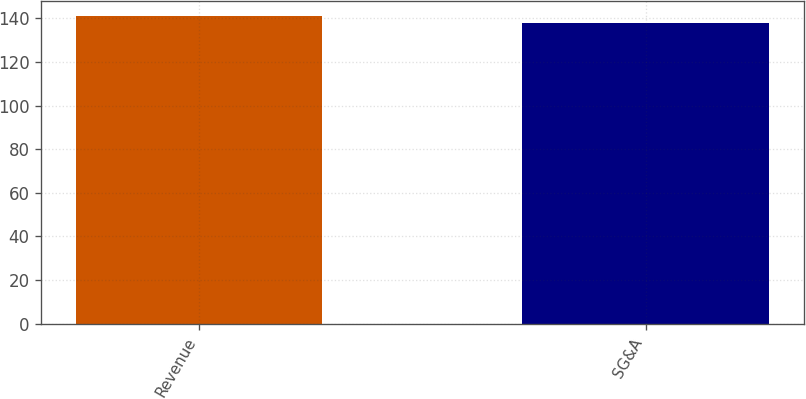<chart> <loc_0><loc_0><loc_500><loc_500><bar_chart><fcel>Revenue<fcel>SG&A<nl><fcel>141<fcel>138<nl></chart> 